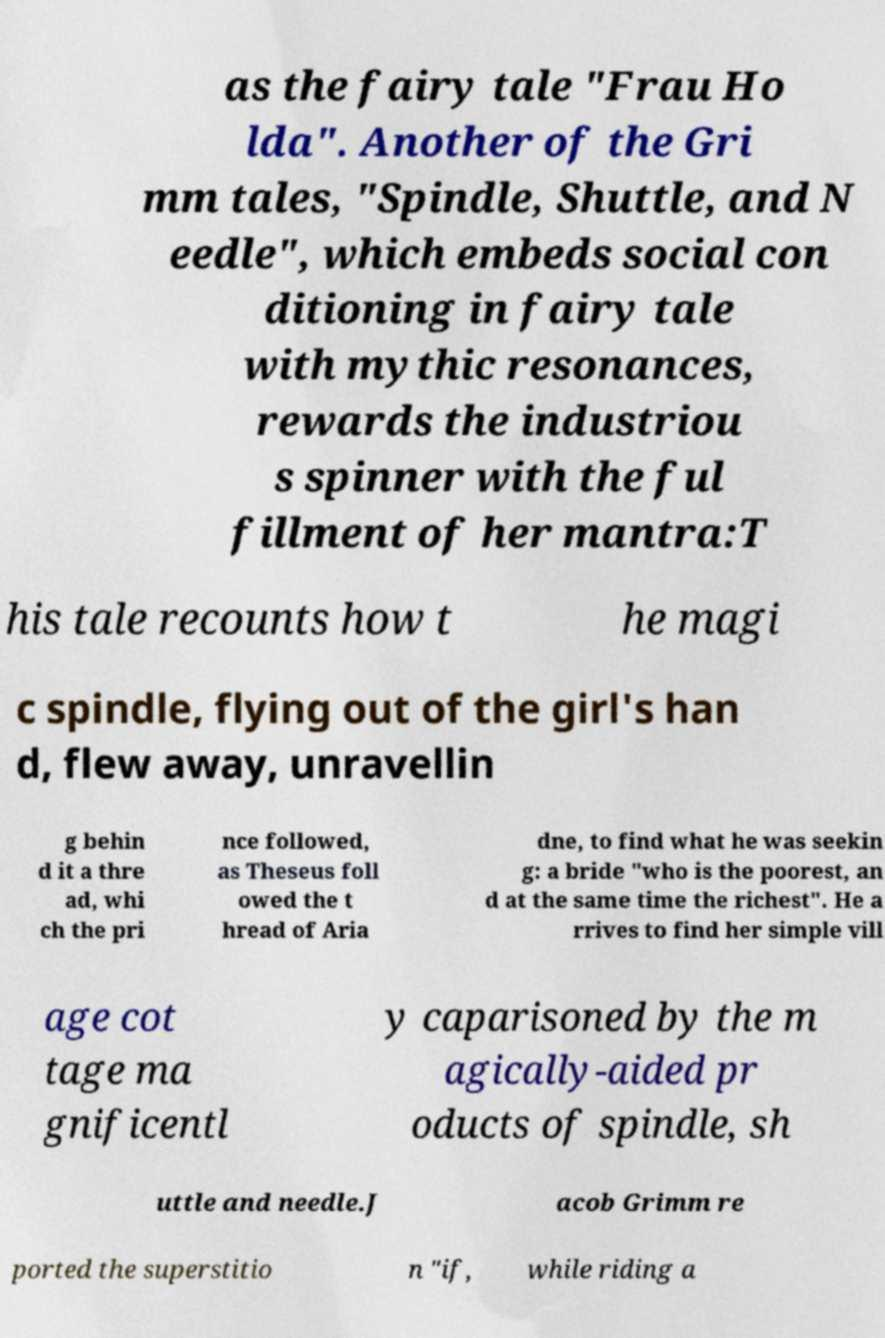I need the written content from this picture converted into text. Can you do that? as the fairy tale "Frau Ho lda". Another of the Gri mm tales, "Spindle, Shuttle, and N eedle", which embeds social con ditioning in fairy tale with mythic resonances, rewards the industriou s spinner with the ful fillment of her mantra:T his tale recounts how t he magi c spindle, flying out of the girl's han d, flew away, unravellin g behin d it a thre ad, whi ch the pri nce followed, as Theseus foll owed the t hread of Aria dne, to find what he was seekin g: a bride "who is the poorest, an d at the same time the richest". He a rrives to find her simple vill age cot tage ma gnificentl y caparisoned by the m agically-aided pr oducts of spindle, sh uttle and needle.J acob Grimm re ported the superstitio n "if, while riding a 